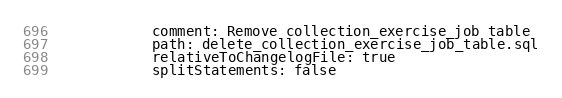Convert code to text. <code><loc_0><loc_0><loc_500><loc_500><_YAML_>            comment: Remove collection_exercise_job table
            path: delete_collection_exercise_job_table.sql
            relativeToChangelogFile: true
            splitStatements: false
</code> 